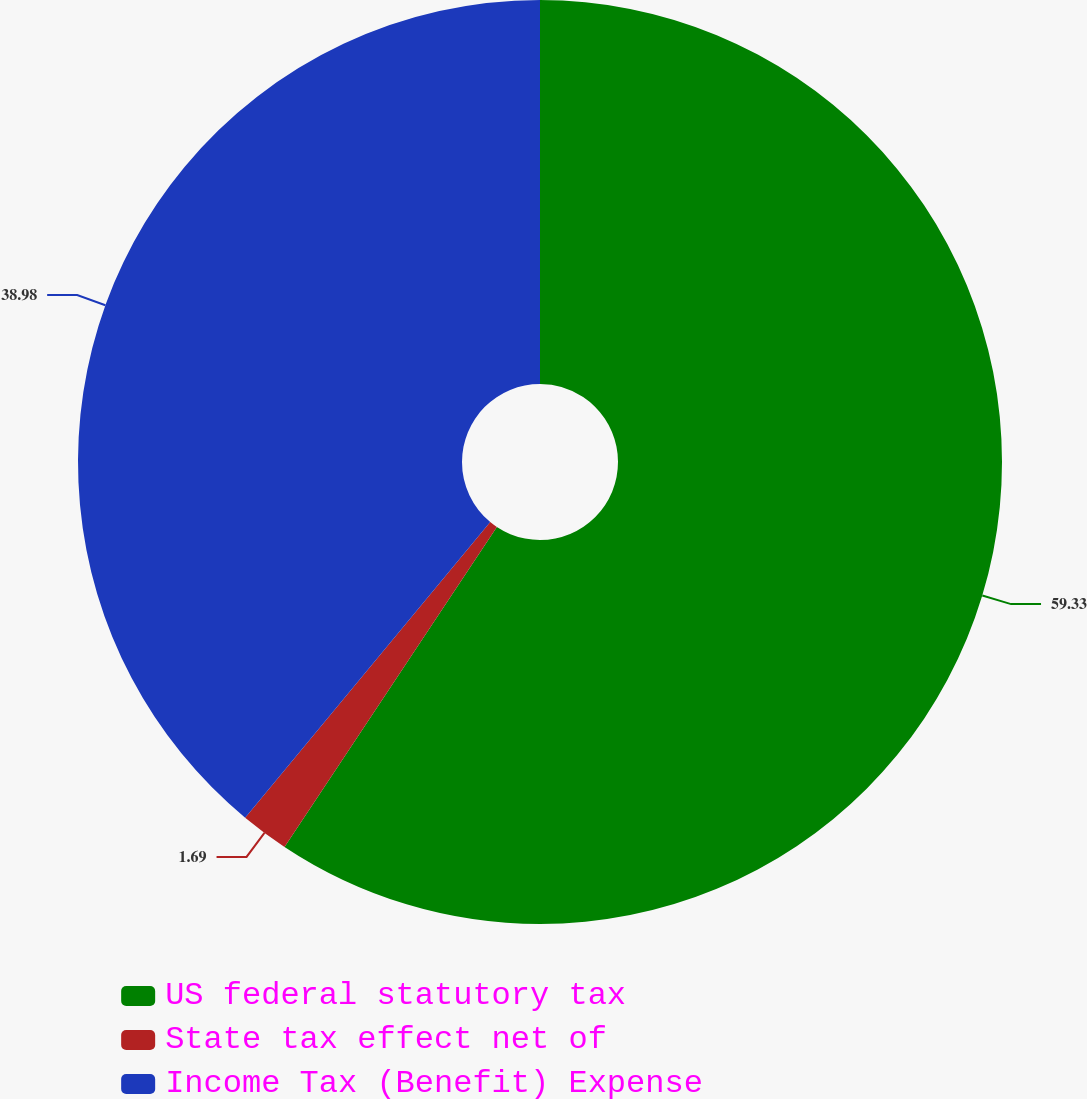Convert chart. <chart><loc_0><loc_0><loc_500><loc_500><pie_chart><fcel>US federal statutory tax<fcel>State tax effect net of<fcel>Income Tax (Benefit) Expense<nl><fcel>59.32%<fcel>1.69%<fcel>38.98%<nl></chart> 